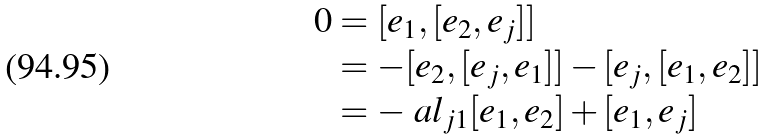Convert formula to latex. <formula><loc_0><loc_0><loc_500><loc_500>0 & = [ e _ { 1 } , [ e _ { 2 } , e _ { j } ] ] \\ & = - [ e _ { 2 } , [ e _ { j } , e _ { 1 } ] ] - [ e _ { j } , [ e _ { 1 } , e _ { 2 } ] ] \\ & = - \ a l _ { j 1 } [ e _ { 1 } , e _ { 2 } ] + [ e _ { 1 } , e _ { j } ]</formula> 